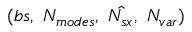Convert formula to latex. <formula><loc_0><loc_0><loc_500><loc_500>( b s , \ N _ { m o d e s } , \ \hat { N _ { s x } } , \ N _ { v a r } )</formula> 